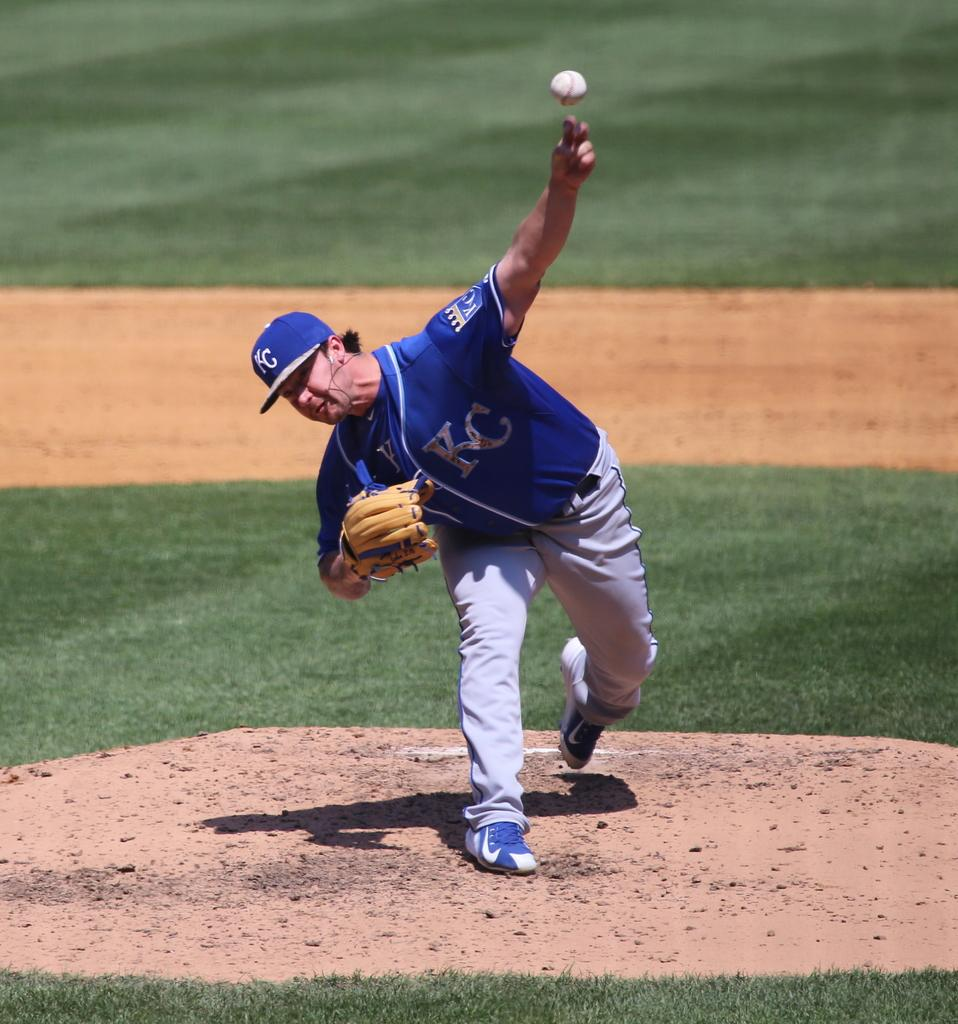<image>
Render a clear and concise summary of the photo. The pitcher for the Kansas City Royals is standing on the pitchers mound, pitching the baseball in his hand. 